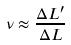<formula> <loc_0><loc_0><loc_500><loc_500>\nu \approx \frac { \Delta L ^ { \prime } } { \Delta L }</formula> 